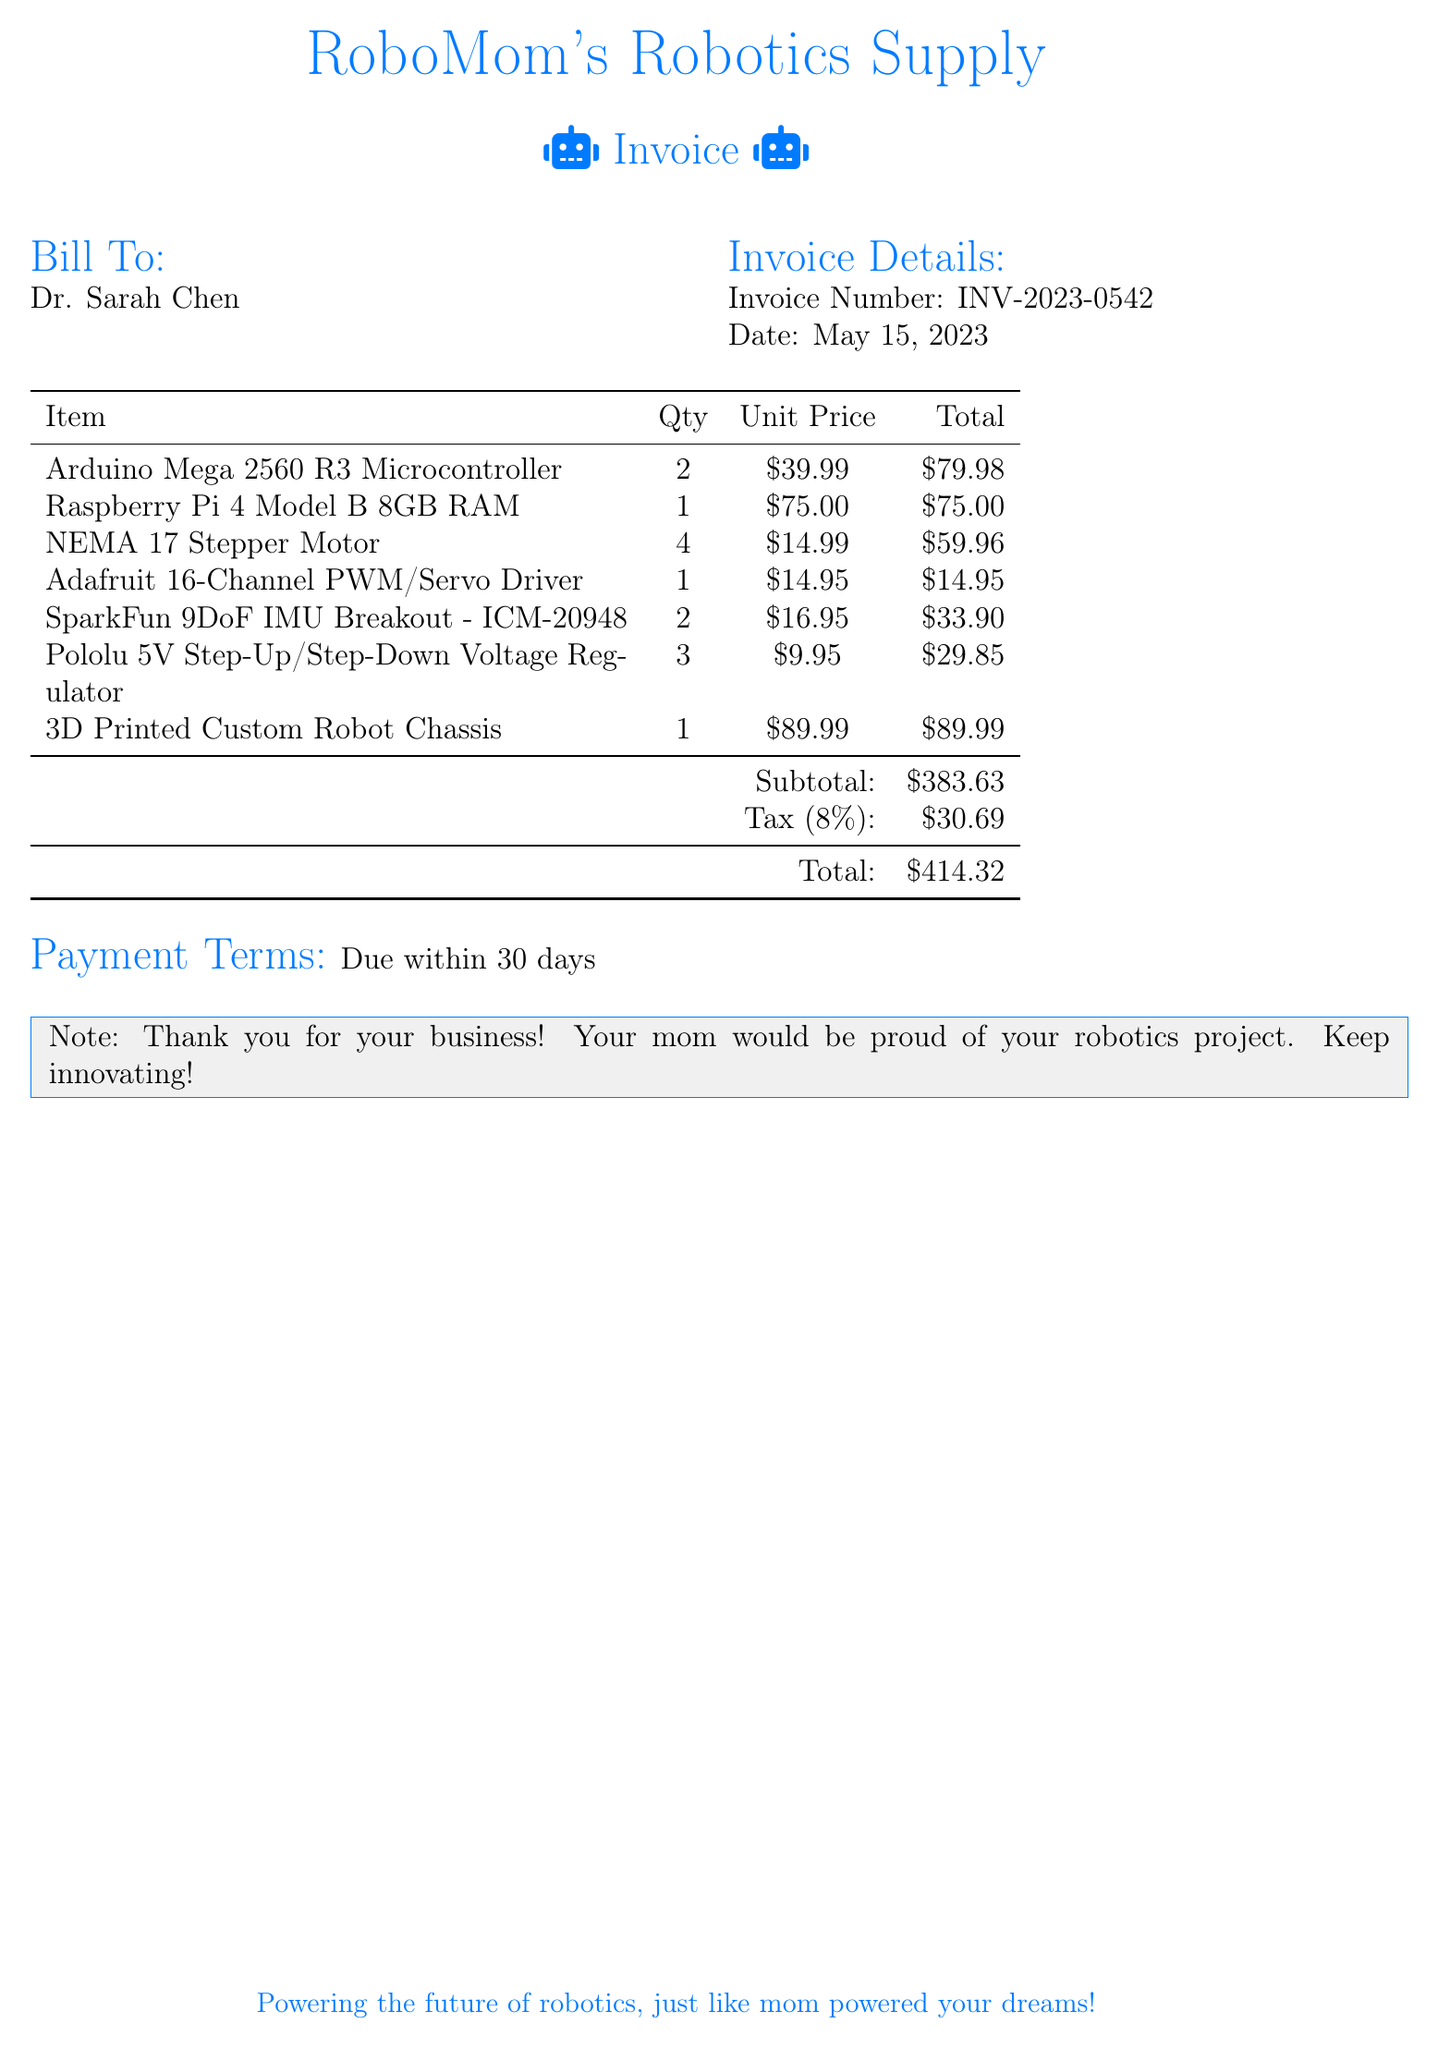What is the invoice number? The invoice number is listed in the invoice details section of the document.
Answer: INV-2023-0542 How many items were purchased in total? The total number of items is the sum of the quantities listed in the itemized table.
Answer: 13 What is the unit price of the Raspberry Pi 4 Model B? The unit price is provided next to the corresponding item in the table.
Answer: $75.00 What is the subtotal amount? The subtotal is calculated prior to tax and is indicated in the summary at the bottom of the table.
Answer: $383.63 Who is the bill addressed to? The "Bill To:" section specifies whom the invoice is addressed.
Answer: Dr. Sarah Chen What is the tax percentage applied? The tax percentage is stated near the total and is relevant to the subtotal amount.
Answer: 8% What is the total amount due? The total amount reflects the final charge after including tax as mentioned in the summary.
Answer: $414.32 When is the payment due? The payment terms specify the due date in relation to the invoice date.
Answer: Due within 30 days How many Arduino Mega 2560 R3 Microcontrollers were purchased? The quantity of specific items purchased is noted in the itemized section of the document.
Answer: 2 